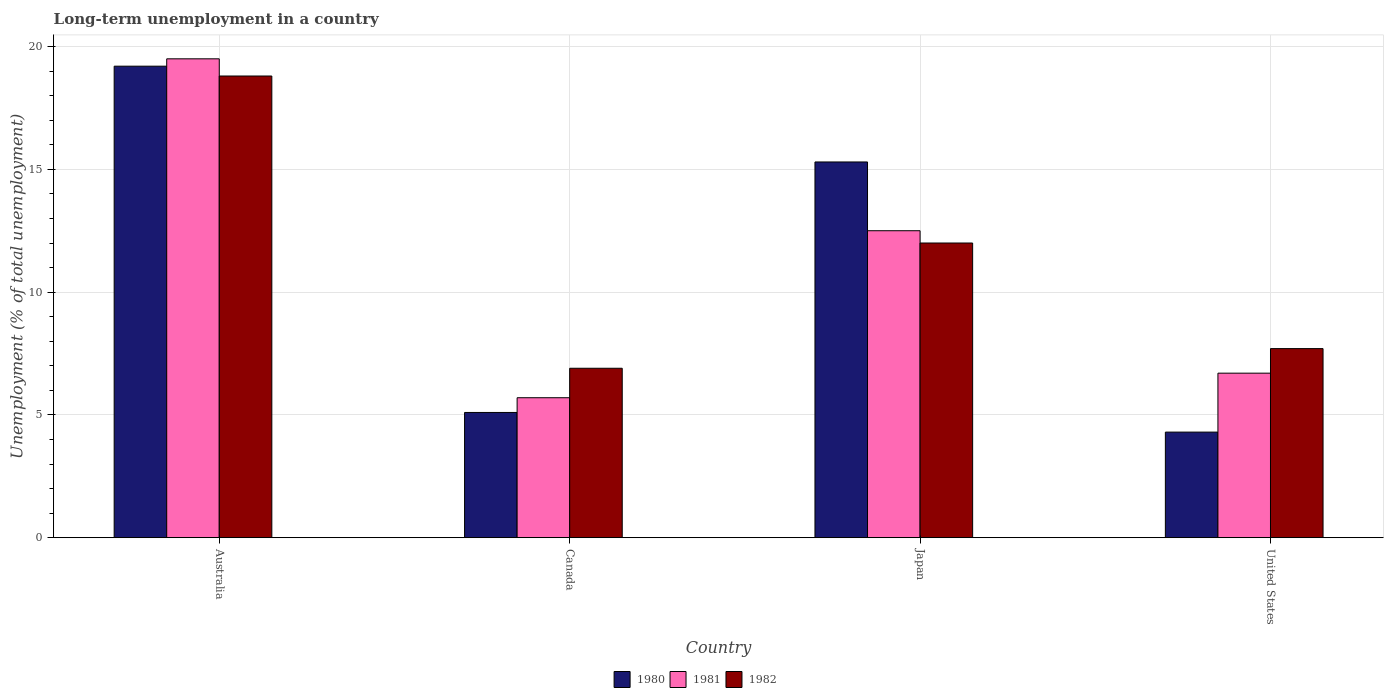How many groups of bars are there?
Keep it short and to the point. 4. Are the number of bars on each tick of the X-axis equal?
Provide a succinct answer. Yes. How many bars are there on the 1st tick from the left?
Provide a short and direct response. 3. In how many cases, is the number of bars for a given country not equal to the number of legend labels?
Provide a succinct answer. 0. What is the percentage of long-term unemployed population in 1981 in Australia?
Provide a succinct answer. 19.5. Across all countries, what is the maximum percentage of long-term unemployed population in 1982?
Your answer should be very brief. 18.8. Across all countries, what is the minimum percentage of long-term unemployed population in 1981?
Provide a succinct answer. 5.7. In which country was the percentage of long-term unemployed population in 1981 minimum?
Provide a short and direct response. Canada. What is the total percentage of long-term unemployed population in 1981 in the graph?
Make the answer very short. 44.4. What is the difference between the percentage of long-term unemployed population in 1981 in Japan and that in United States?
Ensure brevity in your answer.  5.8. What is the difference between the percentage of long-term unemployed population in 1980 in Japan and the percentage of long-term unemployed population in 1982 in Canada?
Your answer should be very brief. 8.4. What is the average percentage of long-term unemployed population in 1982 per country?
Your response must be concise. 11.35. What is the difference between the percentage of long-term unemployed population of/in 1981 and percentage of long-term unemployed population of/in 1980 in Australia?
Offer a very short reply. 0.3. In how many countries, is the percentage of long-term unemployed population in 1981 greater than 3 %?
Your response must be concise. 4. What is the ratio of the percentage of long-term unemployed population in 1982 in Canada to that in Japan?
Your answer should be very brief. 0.58. Is the percentage of long-term unemployed population in 1982 in Canada less than that in Japan?
Keep it short and to the point. Yes. Is the difference between the percentage of long-term unemployed population in 1981 in Japan and United States greater than the difference between the percentage of long-term unemployed population in 1980 in Japan and United States?
Offer a terse response. No. What is the difference between the highest and the second highest percentage of long-term unemployed population in 1981?
Your answer should be very brief. 7. What is the difference between the highest and the lowest percentage of long-term unemployed population in 1982?
Provide a succinct answer. 11.9. In how many countries, is the percentage of long-term unemployed population in 1982 greater than the average percentage of long-term unemployed population in 1982 taken over all countries?
Your answer should be very brief. 2. Is the sum of the percentage of long-term unemployed population in 1980 in Canada and Japan greater than the maximum percentage of long-term unemployed population in 1981 across all countries?
Offer a very short reply. Yes. What does the 3rd bar from the left in United States represents?
Your answer should be very brief. 1982. What does the 1st bar from the right in Canada represents?
Make the answer very short. 1982. Are all the bars in the graph horizontal?
Keep it short and to the point. No. How many countries are there in the graph?
Offer a very short reply. 4. Are the values on the major ticks of Y-axis written in scientific E-notation?
Keep it short and to the point. No. Does the graph contain grids?
Provide a short and direct response. Yes. Where does the legend appear in the graph?
Your response must be concise. Bottom center. How many legend labels are there?
Provide a succinct answer. 3. What is the title of the graph?
Ensure brevity in your answer.  Long-term unemployment in a country. Does "1988" appear as one of the legend labels in the graph?
Ensure brevity in your answer.  No. What is the label or title of the X-axis?
Provide a succinct answer. Country. What is the label or title of the Y-axis?
Your response must be concise. Unemployment (% of total unemployment). What is the Unemployment (% of total unemployment) in 1980 in Australia?
Provide a short and direct response. 19.2. What is the Unemployment (% of total unemployment) of 1981 in Australia?
Provide a short and direct response. 19.5. What is the Unemployment (% of total unemployment) of 1982 in Australia?
Your response must be concise. 18.8. What is the Unemployment (% of total unemployment) in 1980 in Canada?
Your response must be concise. 5.1. What is the Unemployment (% of total unemployment) of 1981 in Canada?
Provide a short and direct response. 5.7. What is the Unemployment (% of total unemployment) of 1982 in Canada?
Your answer should be compact. 6.9. What is the Unemployment (% of total unemployment) of 1980 in Japan?
Keep it short and to the point. 15.3. What is the Unemployment (% of total unemployment) of 1981 in Japan?
Give a very brief answer. 12.5. What is the Unemployment (% of total unemployment) of 1982 in Japan?
Provide a short and direct response. 12. What is the Unemployment (% of total unemployment) of 1980 in United States?
Your answer should be compact. 4.3. What is the Unemployment (% of total unemployment) of 1981 in United States?
Keep it short and to the point. 6.7. What is the Unemployment (% of total unemployment) of 1982 in United States?
Keep it short and to the point. 7.7. Across all countries, what is the maximum Unemployment (% of total unemployment) in 1980?
Provide a short and direct response. 19.2. Across all countries, what is the maximum Unemployment (% of total unemployment) of 1982?
Ensure brevity in your answer.  18.8. Across all countries, what is the minimum Unemployment (% of total unemployment) of 1980?
Provide a short and direct response. 4.3. Across all countries, what is the minimum Unemployment (% of total unemployment) of 1981?
Your response must be concise. 5.7. Across all countries, what is the minimum Unemployment (% of total unemployment) of 1982?
Your response must be concise. 6.9. What is the total Unemployment (% of total unemployment) of 1980 in the graph?
Your answer should be very brief. 43.9. What is the total Unemployment (% of total unemployment) in 1981 in the graph?
Offer a terse response. 44.4. What is the total Unemployment (% of total unemployment) of 1982 in the graph?
Offer a terse response. 45.4. What is the difference between the Unemployment (% of total unemployment) of 1981 in Australia and that in Canada?
Provide a succinct answer. 13.8. What is the difference between the Unemployment (% of total unemployment) in 1982 in Australia and that in Canada?
Offer a terse response. 11.9. What is the difference between the Unemployment (% of total unemployment) of 1980 in Australia and that in Japan?
Your response must be concise. 3.9. What is the difference between the Unemployment (% of total unemployment) in 1982 in Australia and that in Japan?
Your answer should be compact. 6.8. What is the difference between the Unemployment (% of total unemployment) in 1980 in Australia and that in United States?
Your answer should be very brief. 14.9. What is the difference between the Unemployment (% of total unemployment) of 1982 in Australia and that in United States?
Ensure brevity in your answer.  11.1. What is the difference between the Unemployment (% of total unemployment) of 1980 in Canada and that in Japan?
Provide a succinct answer. -10.2. What is the difference between the Unemployment (% of total unemployment) of 1980 in Canada and that in United States?
Keep it short and to the point. 0.8. What is the difference between the Unemployment (% of total unemployment) of 1981 in Canada and that in United States?
Offer a terse response. -1. What is the difference between the Unemployment (% of total unemployment) of 1982 in Canada and that in United States?
Your response must be concise. -0.8. What is the difference between the Unemployment (% of total unemployment) of 1982 in Japan and that in United States?
Offer a terse response. 4.3. What is the difference between the Unemployment (% of total unemployment) of 1980 in Australia and the Unemployment (% of total unemployment) of 1982 in Japan?
Provide a succinct answer. 7.2. What is the difference between the Unemployment (% of total unemployment) in 1981 in Australia and the Unemployment (% of total unemployment) in 1982 in United States?
Your response must be concise. 11.8. What is the difference between the Unemployment (% of total unemployment) in 1980 in Canada and the Unemployment (% of total unemployment) in 1981 in Japan?
Your answer should be very brief. -7.4. What is the difference between the Unemployment (% of total unemployment) in 1980 in Canada and the Unemployment (% of total unemployment) in 1982 in Japan?
Make the answer very short. -6.9. What is the difference between the Unemployment (% of total unemployment) in 1980 in Canada and the Unemployment (% of total unemployment) in 1982 in United States?
Your answer should be very brief. -2.6. What is the difference between the Unemployment (% of total unemployment) in 1981 in Canada and the Unemployment (% of total unemployment) in 1982 in United States?
Keep it short and to the point. -2. What is the difference between the Unemployment (% of total unemployment) of 1980 in Japan and the Unemployment (% of total unemployment) of 1982 in United States?
Offer a very short reply. 7.6. What is the average Unemployment (% of total unemployment) of 1980 per country?
Your response must be concise. 10.97. What is the average Unemployment (% of total unemployment) of 1982 per country?
Keep it short and to the point. 11.35. What is the difference between the Unemployment (% of total unemployment) of 1980 and Unemployment (% of total unemployment) of 1982 in Australia?
Offer a terse response. 0.4. What is the difference between the Unemployment (% of total unemployment) in 1981 and Unemployment (% of total unemployment) in 1982 in Australia?
Provide a succinct answer. 0.7. What is the difference between the Unemployment (% of total unemployment) of 1980 and Unemployment (% of total unemployment) of 1981 in Japan?
Offer a very short reply. 2.8. What is the difference between the Unemployment (% of total unemployment) in 1980 and Unemployment (% of total unemployment) in 1982 in Japan?
Provide a short and direct response. 3.3. What is the difference between the Unemployment (% of total unemployment) in 1981 and Unemployment (% of total unemployment) in 1982 in Japan?
Make the answer very short. 0.5. What is the difference between the Unemployment (% of total unemployment) in 1980 and Unemployment (% of total unemployment) in 1982 in United States?
Keep it short and to the point. -3.4. What is the difference between the Unemployment (% of total unemployment) of 1981 and Unemployment (% of total unemployment) of 1982 in United States?
Offer a terse response. -1. What is the ratio of the Unemployment (% of total unemployment) of 1980 in Australia to that in Canada?
Your answer should be very brief. 3.76. What is the ratio of the Unemployment (% of total unemployment) in 1981 in Australia to that in Canada?
Make the answer very short. 3.42. What is the ratio of the Unemployment (% of total unemployment) in 1982 in Australia to that in Canada?
Give a very brief answer. 2.72. What is the ratio of the Unemployment (% of total unemployment) in 1980 in Australia to that in Japan?
Offer a very short reply. 1.25. What is the ratio of the Unemployment (% of total unemployment) of 1981 in Australia to that in Japan?
Offer a terse response. 1.56. What is the ratio of the Unemployment (% of total unemployment) in 1982 in Australia to that in Japan?
Provide a short and direct response. 1.57. What is the ratio of the Unemployment (% of total unemployment) of 1980 in Australia to that in United States?
Keep it short and to the point. 4.47. What is the ratio of the Unemployment (% of total unemployment) of 1981 in Australia to that in United States?
Your answer should be very brief. 2.91. What is the ratio of the Unemployment (% of total unemployment) of 1982 in Australia to that in United States?
Offer a very short reply. 2.44. What is the ratio of the Unemployment (% of total unemployment) of 1980 in Canada to that in Japan?
Provide a succinct answer. 0.33. What is the ratio of the Unemployment (% of total unemployment) of 1981 in Canada to that in Japan?
Keep it short and to the point. 0.46. What is the ratio of the Unemployment (% of total unemployment) in 1982 in Canada to that in Japan?
Provide a succinct answer. 0.57. What is the ratio of the Unemployment (% of total unemployment) of 1980 in Canada to that in United States?
Your answer should be compact. 1.19. What is the ratio of the Unemployment (% of total unemployment) of 1981 in Canada to that in United States?
Your response must be concise. 0.85. What is the ratio of the Unemployment (% of total unemployment) of 1982 in Canada to that in United States?
Provide a succinct answer. 0.9. What is the ratio of the Unemployment (% of total unemployment) of 1980 in Japan to that in United States?
Provide a succinct answer. 3.56. What is the ratio of the Unemployment (% of total unemployment) in 1981 in Japan to that in United States?
Ensure brevity in your answer.  1.87. What is the ratio of the Unemployment (% of total unemployment) of 1982 in Japan to that in United States?
Provide a short and direct response. 1.56. What is the difference between the highest and the second highest Unemployment (% of total unemployment) in 1980?
Make the answer very short. 3.9. What is the difference between the highest and the second highest Unemployment (% of total unemployment) of 1981?
Provide a short and direct response. 7. What is the difference between the highest and the second highest Unemployment (% of total unemployment) in 1982?
Offer a very short reply. 6.8. What is the difference between the highest and the lowest Unemployment (% of total unemployment) in 1980?
Offer a very short reply. 14.9. 